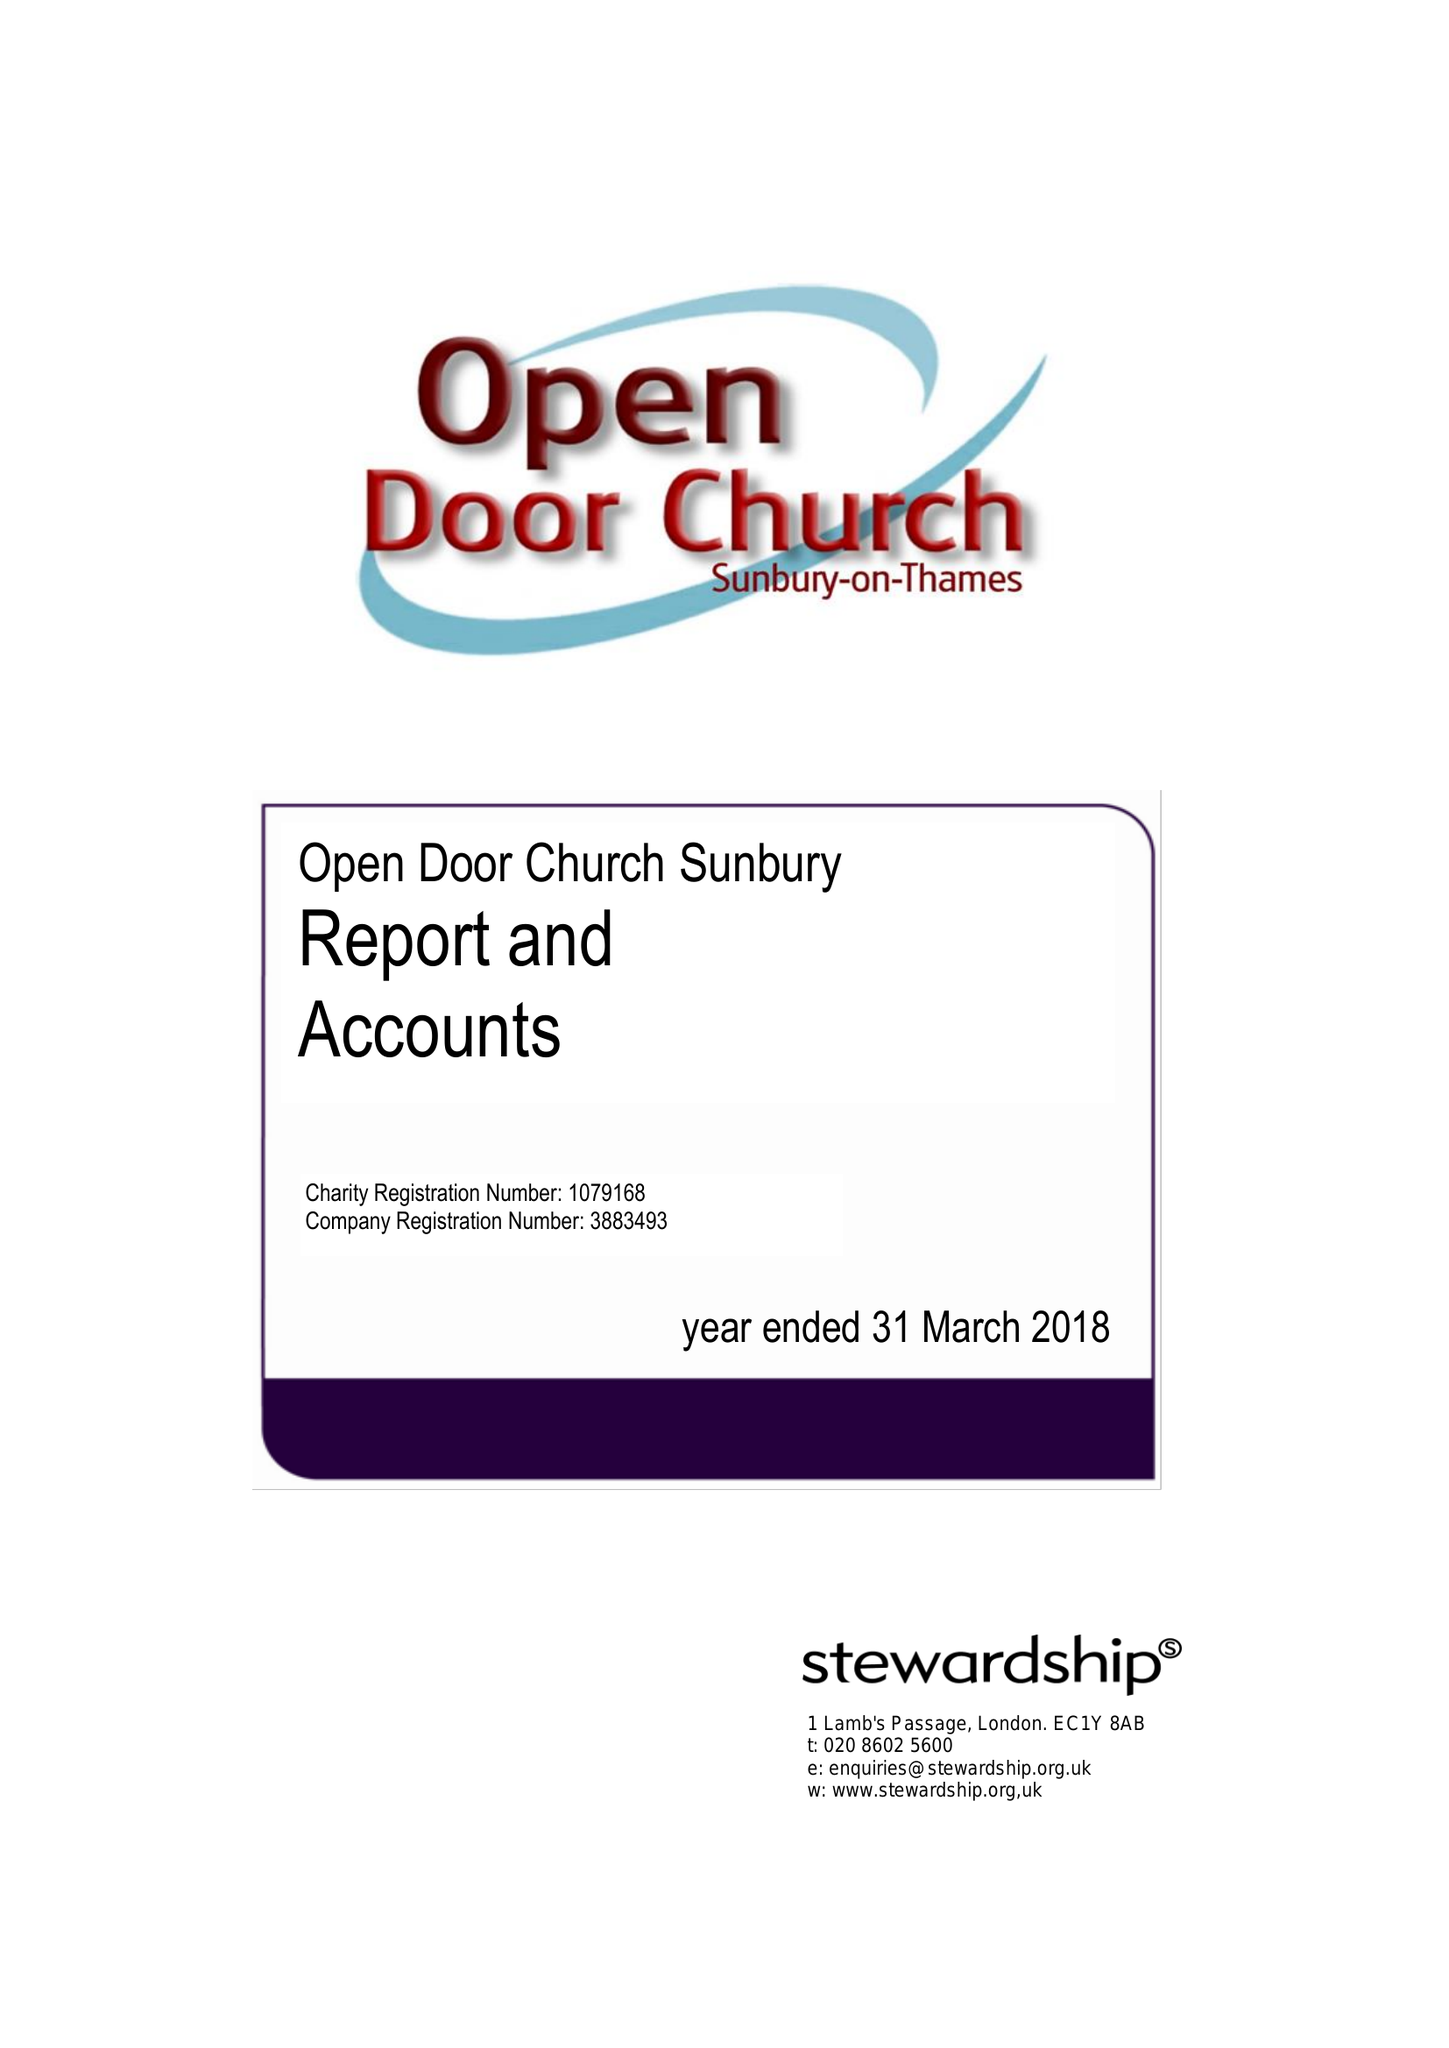What is the value for the report_date?
Answer the question using a single word or phrase. 2018-03-31 